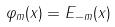Convert formula to latex. <formula><loc_0><loc_0><loc_500><loc_500>\varphi _ { m } ( x ) = E _ { - m } ( x )</formula> 